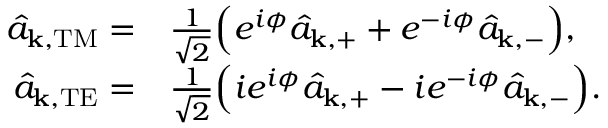Convert formula to latex. <formula><loc_0><loc_0><loc_500><loc_500>\begin{array} { r l } { \hat { a } _ { k , T M } = } & { \frac { 1 } { \sqrt { 2 } } \left ( e ^ { i \phi } \hat { a } _ { k , + } + e ^ { - i \phi } \hat { a } _ { k , - } \right ) , } \\ { \hat { a } _ { k , T E } = } & { \frac { 1 } { \sqrt { 2 } } \left ( i e ^ { i \phi } \hat { a } _ { k , + } - i e ^ { - i \phi } \hat { a } _ { k , - } \right ) . } \end{array}</formula> 